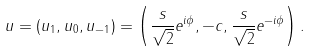<formula> <loc_0><loc_0><loc_500><loc_500>u = ( u _ { 1 } , u _ { 0 } , u _ { - 1 } ) = \left ( \frac { s } { \sqrt { 2 } } e ^ { i \phi } , - c , \frac { s } { \sqrt { 2 } } e ^ { - i \phi } \right ) .</formula> 